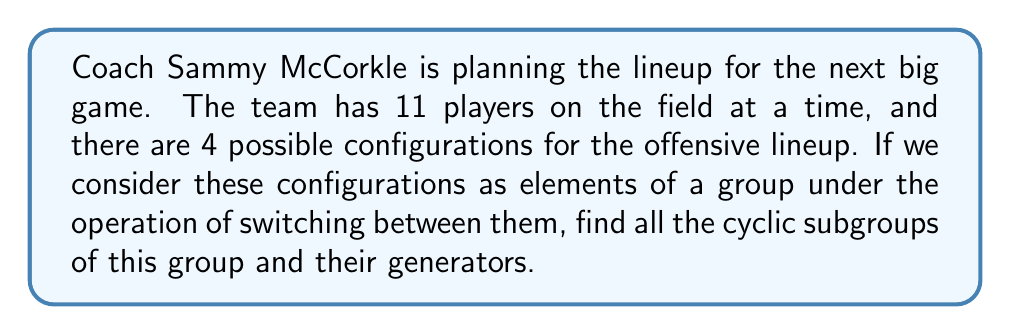Help me with this question. Let's approach this step-by-step:

1) First, let's define our group. We have 4 possible configurations, so our group has 4 elements. Let's call them $a$, $b$, $c$, and $d$. The identity element (no change in configuration) will be $e$.

2) The group operation is switching between configurations. This forms a cyclic group of order 4, which is isomorphic to $\mathbb{Z}_4$ under addition modulo 4.

3) To find the cyclic subgroups, we need to consider the order of each element:

   - $e$ has order 1: $\{e\}$
   - $a$, $b$, and $c$ each have order 4: $\{e, a, a^2, a^3\}$, $\{e, b, b^2, b^3\}$, $\{e, c, c^2, c^3\}$
   - $a^2$, $b^2$, and $c^2$ each have order 2: $\{e, a^2\}$, $\{e, b^2\}$, $\{e, c^2\}$

4) The cyclic subgroups are:

   - $\langle e \rangle = \{e\}$
   - $\langle a \rangle = \langle c \rangle = \langle b \rangle = \{e, a, a^2, a^3\}$ (the whole group)
   - $\langle a^2 \rangle = \langle b^2 \rangle = \langle c^2 \rangle = \{e, a^2\}$

5) The generators for each subgroup are:

   - For $\{e\}$: $e$
   - For $\{e, a, a^2, a^3\}$: $a$, $b$, $c$, $a^3$, $b^3$, $c^3$
   - For $\{e, a^2\}$: $a^2$, $b^2$, $c^2$
Answer: The cyclic subgroups and their generators are:
1) $\{e\}$ with generator $e$
2) $\{e, a, a^2, a^3\}$ with generators $a$, $b$, $c$, $a^3$, $b^3$, $c^3$
3) $\{e, a^2\}$ with generators $a^2$, $b^2$, $c^2$ 